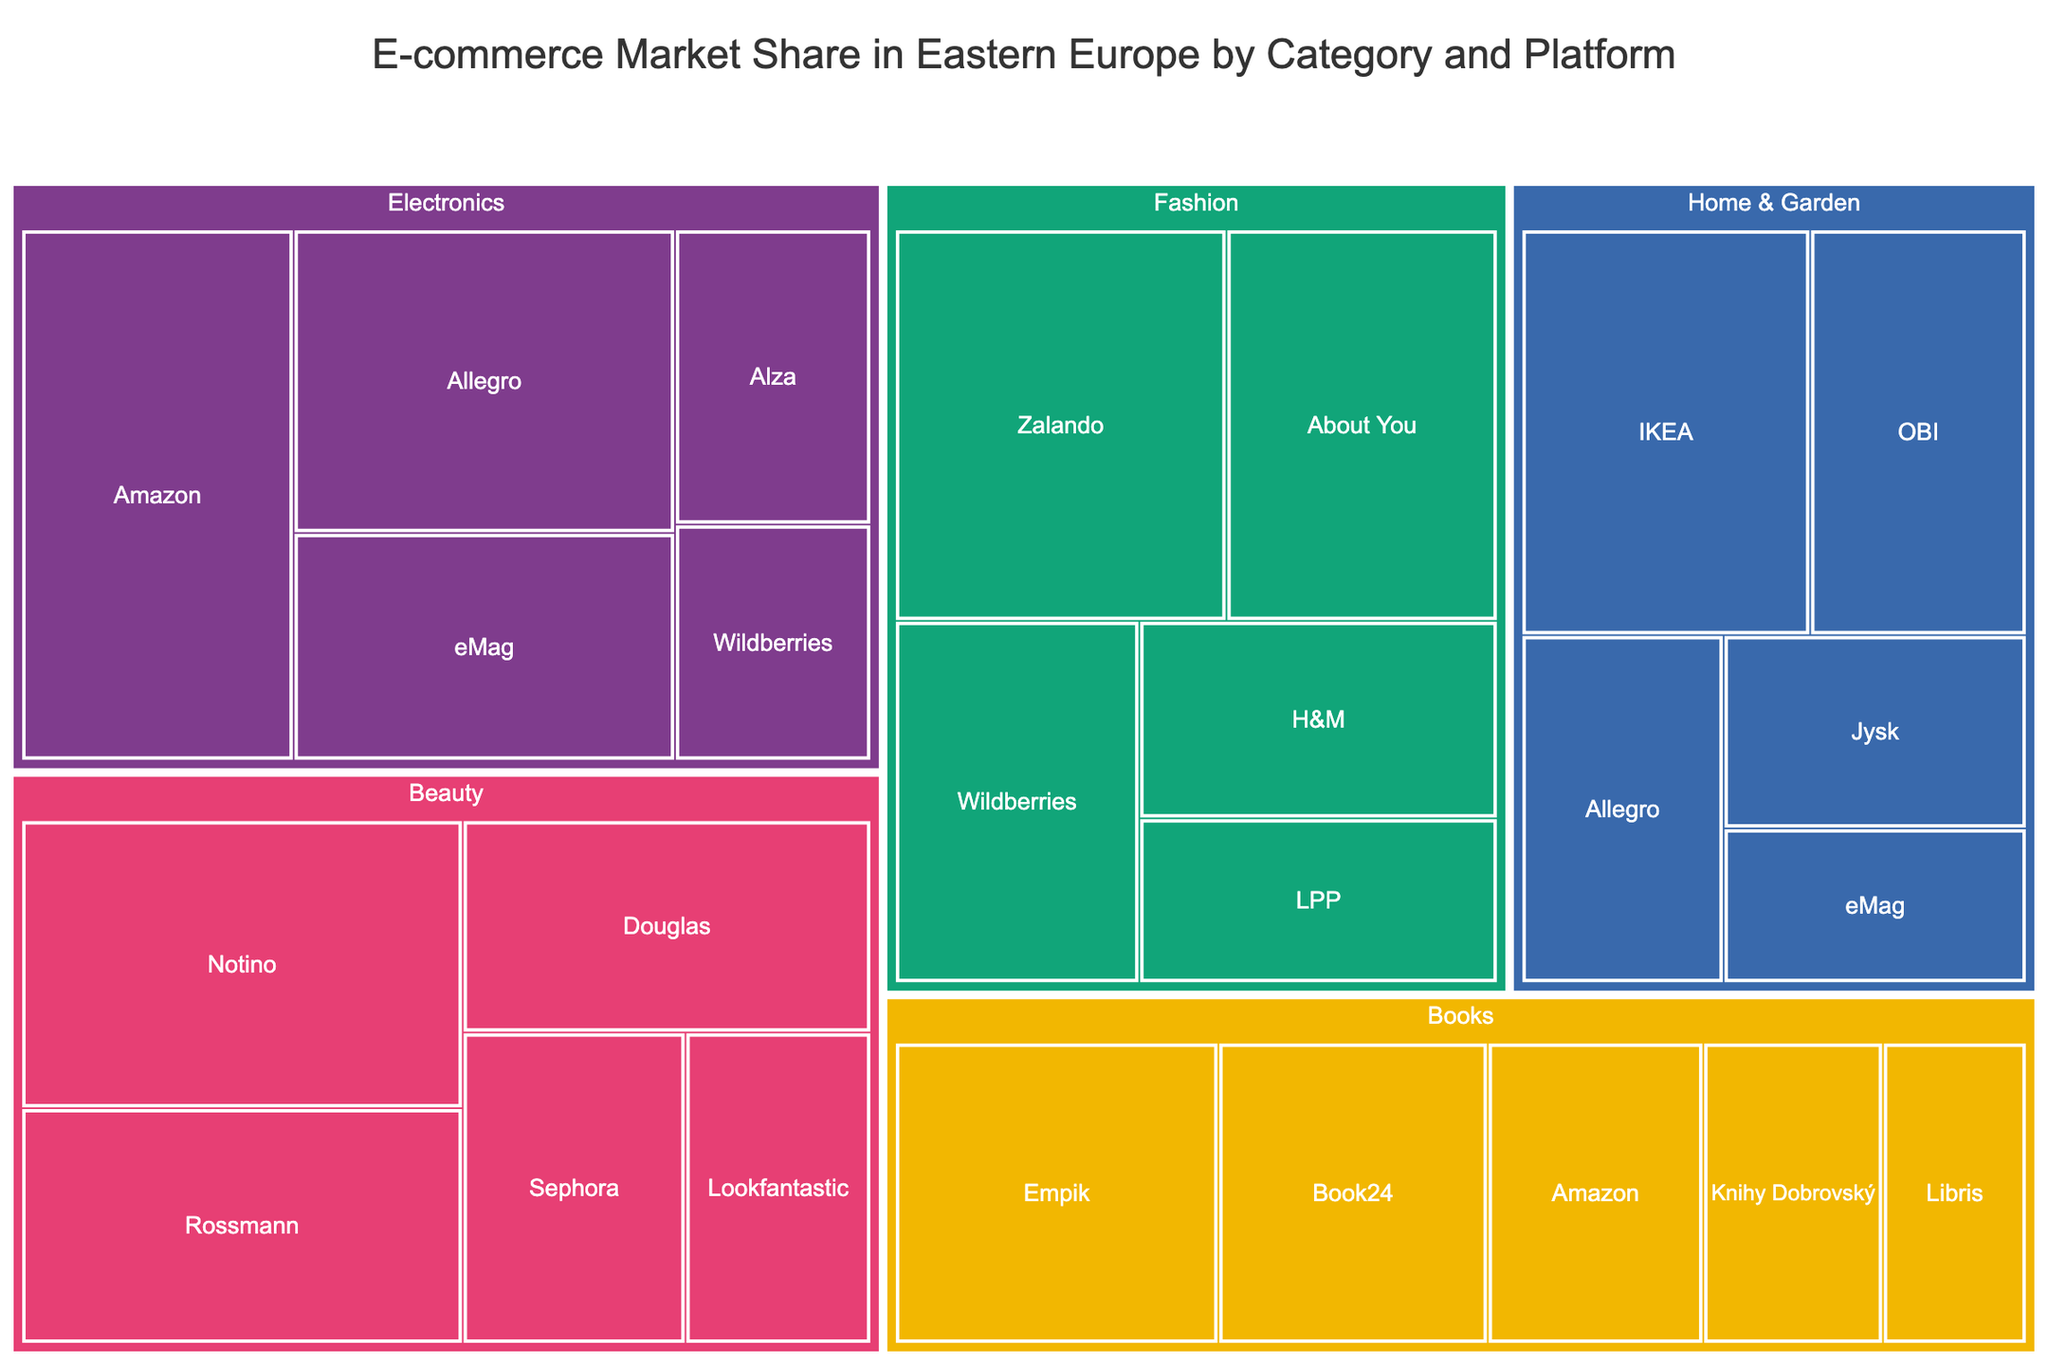What is the title of the treemap? The title is usually located at the top of the treemap. It provides a brief description of what the treemap is about. In this case, the title is 'E-commerce Market Share in Eastern Europe by Category and Platform'.
Answer: E-commerce Market Share in Eastern Europe by Category and Platform Which platform has the largest market share in the Electronics category? In a treemap, the area size represents the market share. Within the Electronics category, the largest area belongs to Amazon with a market share of 25%.
Answer: Amazon How many product categories are represented in the treemap? The different sections of the treemap are divided by product categories, each marked with a unique color. By counting these sections, it can be determined how many categories there are. There are 5 categories: Electronics, Fashion, Home & Garden, Books, and Beauty.
Answer: 5 Which category has the platform with the smallest market share, and which platform is it? Look for the smallest rectangle overall, and identify its category and platform. In this treemap, the smallest market share belongs to the Beauty category, specifically Lookfantastic with a market share of 10%.
Answer: Beauty, Lookfantastic What is the total market share of platforms in the Fashion category? To find the total market share for Fashion, sum up the market shares of all platforms in this category: Zalando (22) + About You (18) + Wildberries (15) + H&M (12) + LPP (10) = 77%.
Answer: 77% Which platform appears in both the Electronics and Home & Garden categories, and what are their market shares in each? Identify the platform that appears in both categories and check their respective market shares. Allegro is present in both with a market share of 20% in Electronics and 12% in Home & Garden.
Answer: Allegro, 20% in Electronics, 12% in Home & Garden Between Books and Beauty, which category has a larger total market share, and by how much? First, sum up the market shares of all platforms in the Books category: Empik (18) + Book24 (15) + Amazon (12) + Knihy Dobrovský (10) + Libris (8) = 63%. Then sum up for Beauty: Notino (22) + Rossmann (18) + Douglas (15) + Sephora (12) + Lookfantastic (10) = 77%. Compare the totals, Beauty has 77% - 63% = 14% more market share.
Answer: Beauty, by 14% Which category has the most balanced distribution of market share among platforms, and how do you know? Assess the areas within each category to see the evenness of share distribution. Home & Garden has the most balanced distribution since the areas (market shares) of IKEA (20), OBI (15), Allegro (12), Jysk (10), and eMag (8) are relatively close to each other.
Answer: Home & Garden How does the market share of Empik in the Books category compare to Amazon in the same category? Find both platforms in the Books category and compare their market shares. Empik has a market share of 18%, while Amazon has 12%. Since 18% > 12%, Empik has a higher market share.
Answer: Empik has a higher market share by 6% If Allegro's total market share combined across all categories is measured, what is it? Sum up Allegro's market share across all categories: Electronics (20%) + Home & Garden (12%) = 32%. Since Allegro only appears in these two categories, the total market share is 32%.
Answer: 32% 